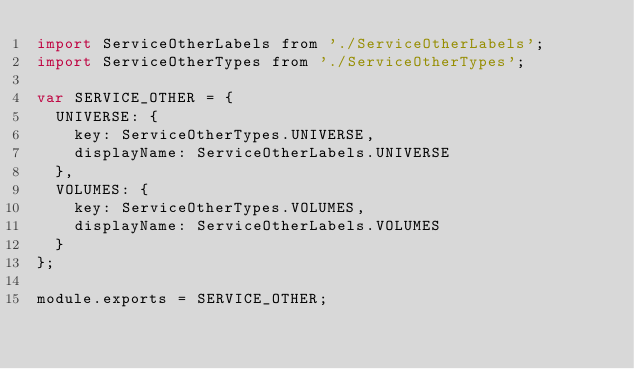<code> <loc_0><loc_0><loc_500><loc_500><_JavaScript_>import ServiceOtherLabels from './ServiceOtherLabels';
import ServiceOtherTypes from './ServiceOtherTypes';

var SERVICE_OTHER = {
  UNIVERSE: {
    key: ServiceOtherTypes.UNIVERSE,
    displayName: ServiceOtherLabels.UNIVERSE
  },
  VOLUMES: {
    key: ServiceOtherTypes.VOLUMES,
    displayName: ServiceOtherLabels.VOLUMES
  }
};

module.exports = SERVICE_OTHER;
</code> 